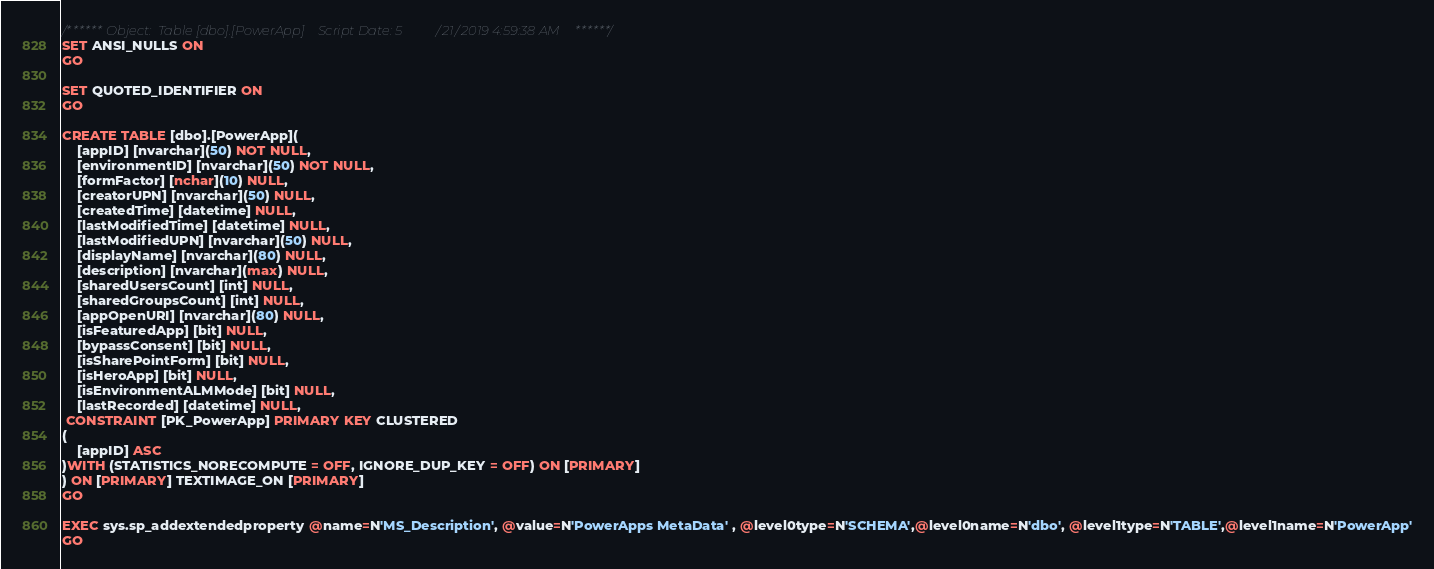<code> <loc_0><loc_0><loc_500><loc_500><_SQL_>/****** Object:  Table [dbo].[PowerApp]    Script Date: 5/21/2019 4:59:38 AM ******/
SET ANSI_NULLS ON
GO

SET QUOTED_IDENTIFIER ON
GO

CREATE TABLE [dbo].[PowerApp](
	[appID] [nvarchar](50) NOT NULL,
	[environmentID] [nvarchar](50) NOT NULL,
	[formFactor] [nchar](10) NULL,
	[creatorUPN] [nvarchar](50) NULL,
	[createdTime] [datetime] NULL,
	[lastModifiedTime] [datetime] NULL,
	[lastModifiedUPN] [nvarchar](50) NULL,
	[displayName] [nvarchar](80) NULL,
	[description] [nvarchar](max) NULL,
	[sharedUsersCount] [int] NULL,
	[sharedGroupsCount] [int] NULL,
	[appOpenURI] [nvarchar](80) NULL,
	[isFeaturedApp] [bit] NULL,
	[bypassConsent] [bit] NULL,
	[isSharePointForm] [bit] NULL,
	[isHeroApp] [bit] NULL,
	[isEnvironmentALMMode] [bit] NULL,
	[lastRecorded] [datetime] NULL,
 CONSTRAINT [PK_PowerApp] PRIMARY KEY CLUSTERED 
(
	[appID] ASC
)WITH (STATISTICS_NORECOMPUTE = OFF, IGNORE_DUP_KEY = OFF) ON [PRIMARY]
) ON [PRIMARY] TEXTIMAGE_ON [PRIMARY]
GO

EXEC sys.sp_addextendedproperty @name=N'MS_Description', @value=N'PowerApps MetaData' , @level0type=N'SCHEMA',@level0name=N'dbo', @level1type=N'TABLE',@level1name=N'PowerApp'
GO</code> 